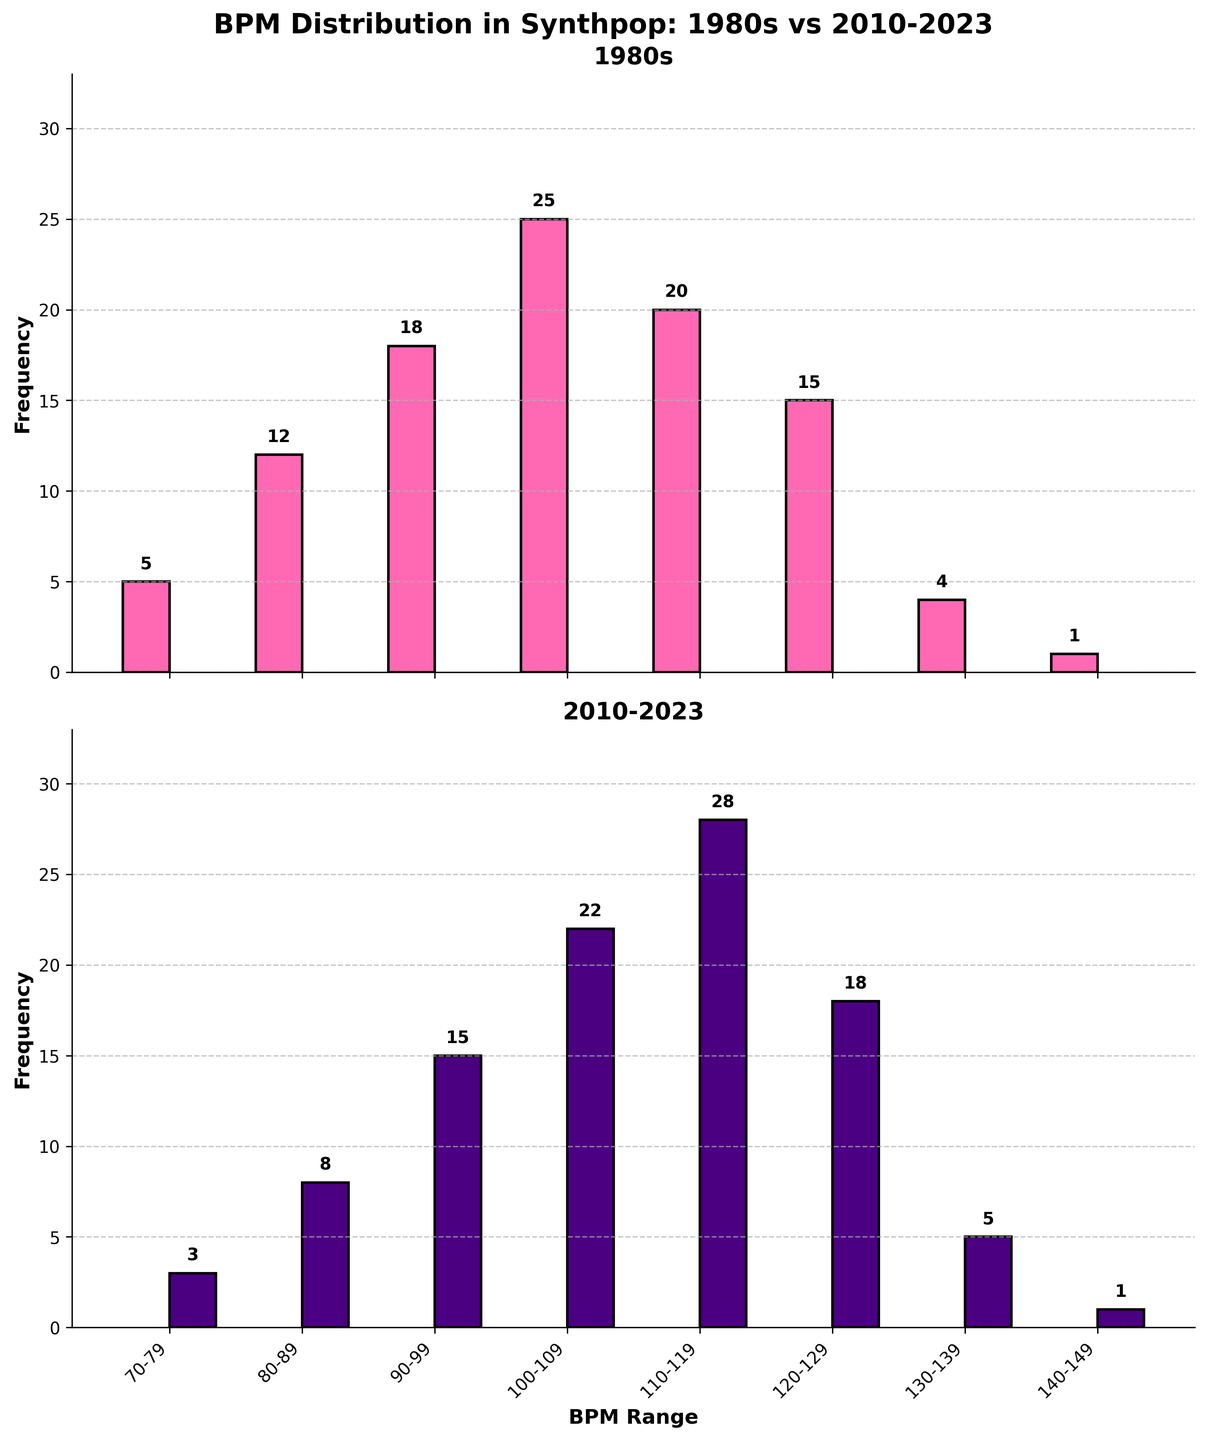What is the most common BPM range for synthpop songs from the 1980s? The highest bar in the 1980s subplot represents the BPM range 100-109 with a frequency of 25, indicating it is the most common.
Answer: 100-109 What is the difference in the number of songs in the 110-119 BPM range between the 1980s and 2010-2023? The 1980s have a count of 20 songs in the 110-119 BPM range, whereas 2010-2023 have 28. The difference is calculated as 28 - 20.
Answer: 8 Which BPM range has the least number of synthpop songs in both the 1980s and 2010-2023? In both subplots, the 140-149 BPM range has the smallest bars, each with a height of 1, representing the least number of songs.
Answer: 140-149 In which BPM range do 2010-2023 synthpop songs significantly outnumber those from the 1980s? In the 110-119 BPM range, the subplots show a larger disparity, with 2010-2023 having 28 songs compared to the 1980s' 20 songs.
Answer: 110-119 What is the combined frequency of synthpop songs in the BPM range of 90-99 over both decades? The combined frequency can be found by adding the 1980s count (18) and the 2010-2023 count (15), which totals 33 songs.
Answer: 33 Which BPM range shows the smallest decrease in song count from 1980s to 2010-2023? Both the 130-139 and 140-149 BPM ranges exhibit only a one-song difference, from 4 to 5 and 1 to 1 respectively, but only 140-149 shows no decrease at all.
Answer: 140-149 How many more songs in the 2010-2023 era fall within the 120-129 BPM range compared to the 1980s? The 1980s have 15 songs while 2010-2023 have 18 in the 120-129 BPM range, calculated by subtracting 15 from 18.
Answer: 3 What is the average frequency of songs in the 100-109 BPM range over both decades? The average frequency is calculated by summing the counts from both eras (25 from 1980s and 22 from 2010-2023), which totals 47, and then dividing by 2.
Answer: 23.5 